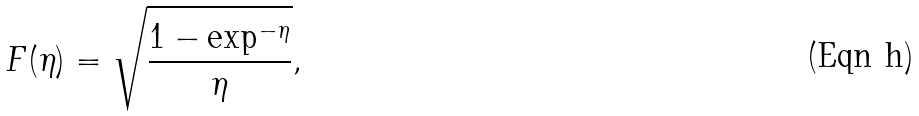Convert formula to latex. <formula><loc_0><loc_0><loc_500><loc_500>F ( \eta ) = \sqrt { \frac { 1 - \exp ^ { - \eta } } { \eta } } ,</formula> 